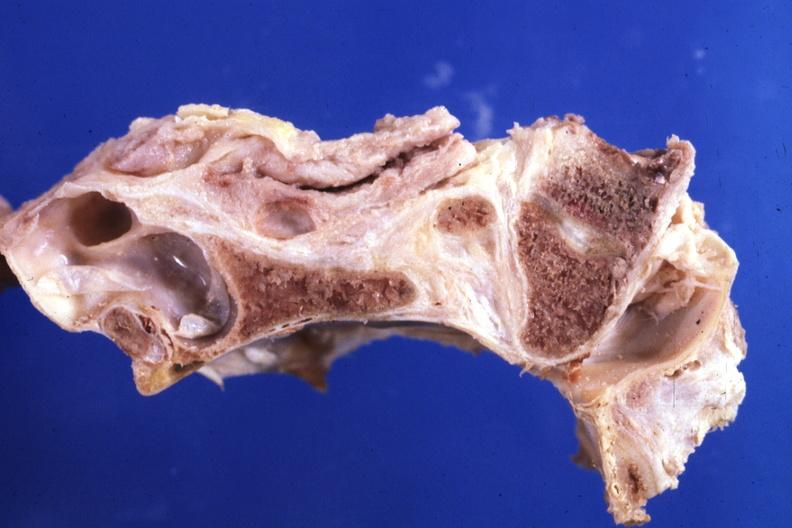what is present?
Answer the question using a single word or phrase. Rheumatoid arthritis 